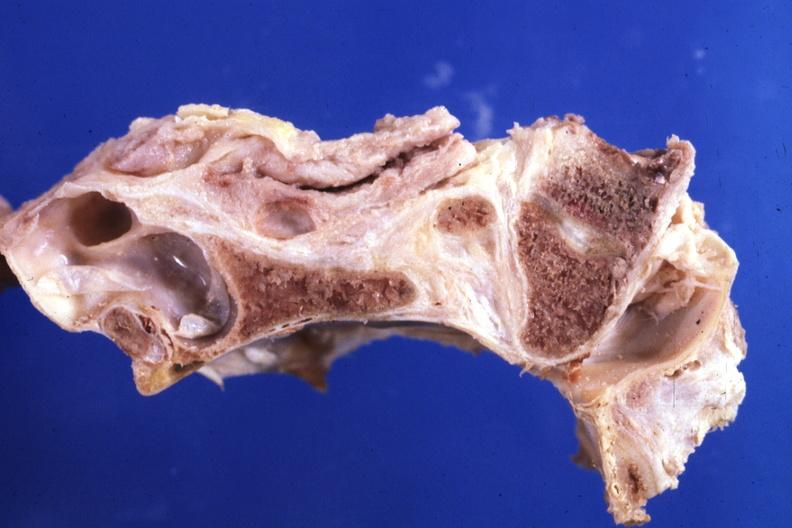what is present?
Answer the question using a single word or phrase. Rheumatoid arthritis 